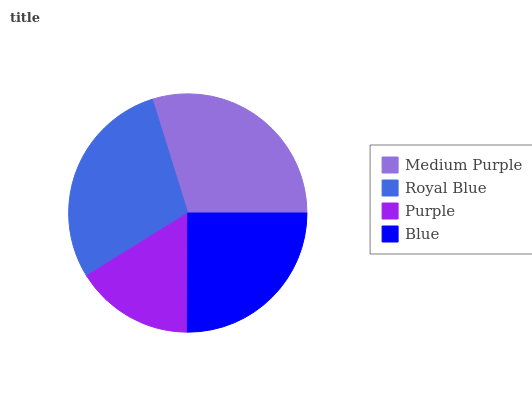Is Purple the minimum?
Answer yes or no. Yes. Is Medium Purple the maximum?
Answer yes or no. Yes. Is Royal Blue the minimum?
Answer yes or no. No. Is Royal Blue the maximum?
Answer yes or no. No. Is Medium Purple greater than Royal Blue?
Answer yes or no. Yes. Is Royal Blue less than Medium Purple?
Answer yes or no. Yes. Is Royal Blue greater than Medium Purple?
Answer yes or no. No. Is Medium Purple less than Royal Blue?
Answer yes or no. No. Is Royal Blue the high median?
Answer yes or no. Yes. Is Blue the low median?
Answer yes or no. Yes. Is Purple the high median?
Answer yes or no. No. Is Royal Blue the low median?
Answer yes or no. No. 